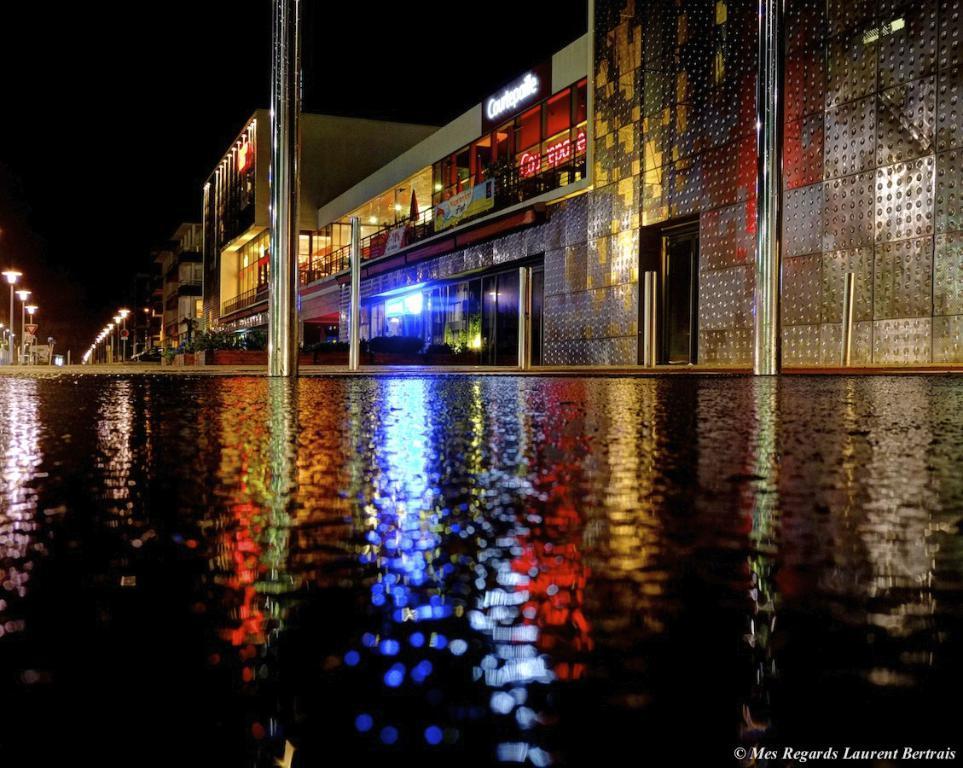Please provide a concise description of this image. In this picture I can see there is a pool, there are few buildings at right and there are a few poles with lights and the sky is clear. 